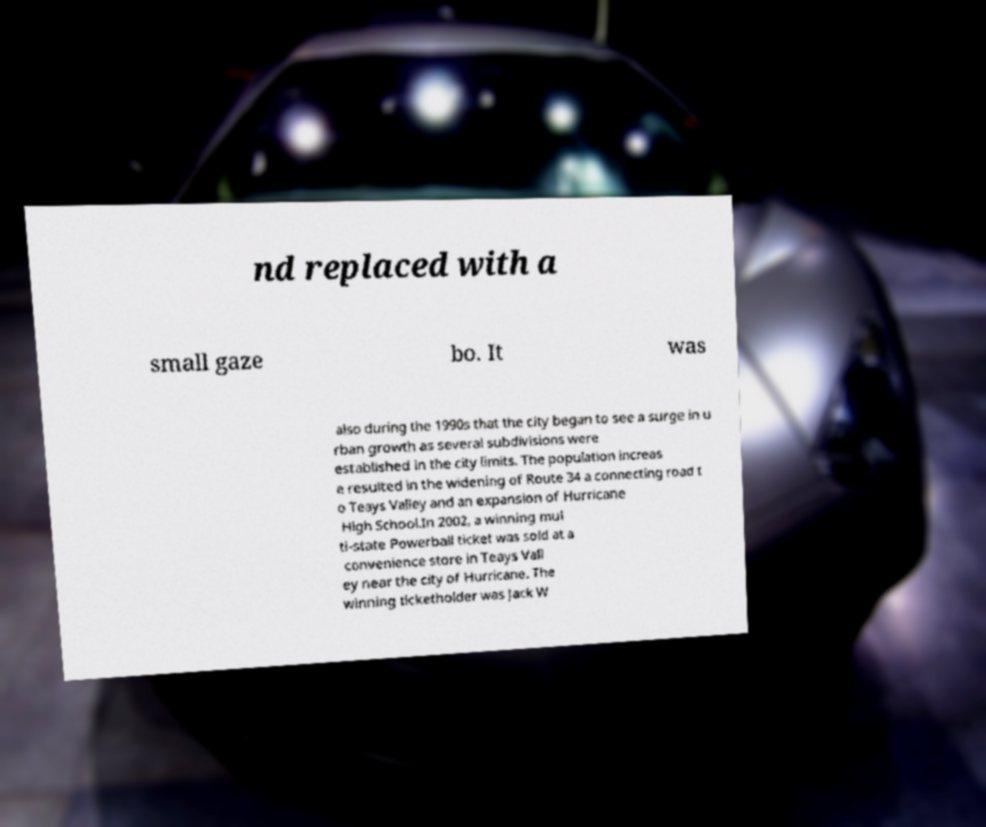I need the written content from this picture converted into text. Can you do that? nd replaced with a small gaze bo. It was also during the 1990s that the city began to see a surge in u rban growth as several subdivisions were established in the city limits. The population increas e resulted in the widening of Route 34 a connecting road t o Teays Valley and an expansion of Hurricane High School.In 2002, a winning mul ti-state Powerball ticket was sold at a convenience store in Teays Vall ey near the city of Hurricane. The winning ticketholder was Jack W 